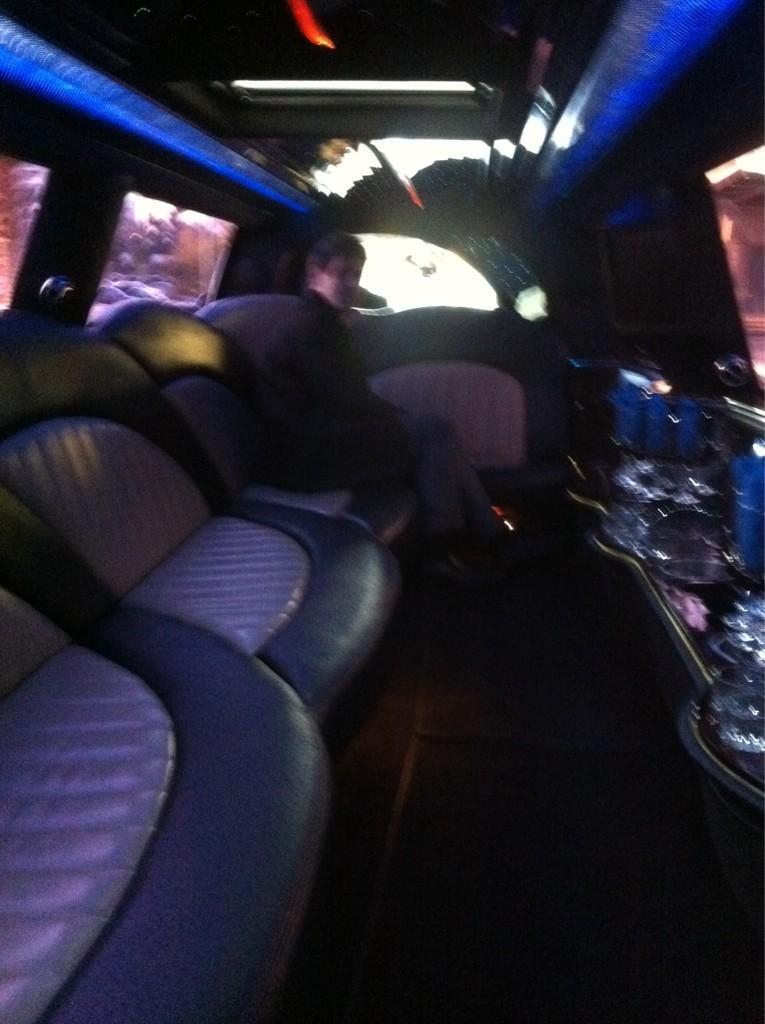Describe this image in one or two sentences. In this image I can see there is a person sitting on the seat and there is an object at right side, there are few windows and lights attached to the ceiling. 